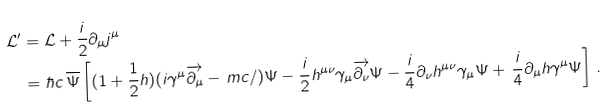<formula> <loc_0><loc_0><loc_500><loc_500>\mathcal { L ^ { \prime } } & = \mathcal { L } + \frac { i } { 2 } \partial _ { \mu } j ^ { \mu } \\ & = \hbar { c } \, \overline { \Psi } \left [ ( 1 + { \frac { 1 } { 2 } } h ) ( i \gamma ^ { \mu } \overrightarrow { \partial _ { \mu } } - \, { m c / } ) \Psi - \frac { i } { 2 } h ^ { \mu \nu } \gamma _ { \mu } \overrightarrow { \partial _ { \nu } } \Psi - \frac { i } { 4 } \partial _ { \nu } h ^ { \mu \nu } \gamma _ { \mu } \Psi + \, \frac { i } { 4 } \partial _ { \mu } h \gamma ^ { \mu } \Psi \right ] \, .</formula> 